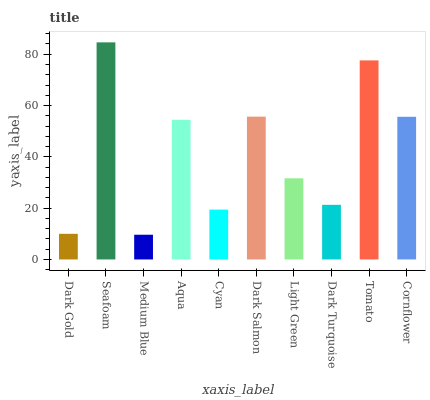Is Medium Blue the minimum?
Answer yes or no. Yes. Is Seafoam the maximum?
Answer yes or no. Yes. Is Seafoam the minimum?
Answer yes or no. No. Is Medium Blue the maximum?
Answer yes or no. No. Is Seafoam greater than Medium Blue?
Answer yes or no. Yes. Is Medium Blue less than Seafoam?
Answer yes or no. Yes. Is Medium Blue greater than Seafoam?
Answer yes or no. No. Is Seafoam less than Medium Blue?
Answer yes or no. No. Is Aqua the high median?
Answer yes or no. Yes. Is Light Green the low median?
Answer yes or no. Yes. Is Cornflower the high median?
Answer yes or no. No. Is Medium Blue the low median?
Answer yes or no. No. 